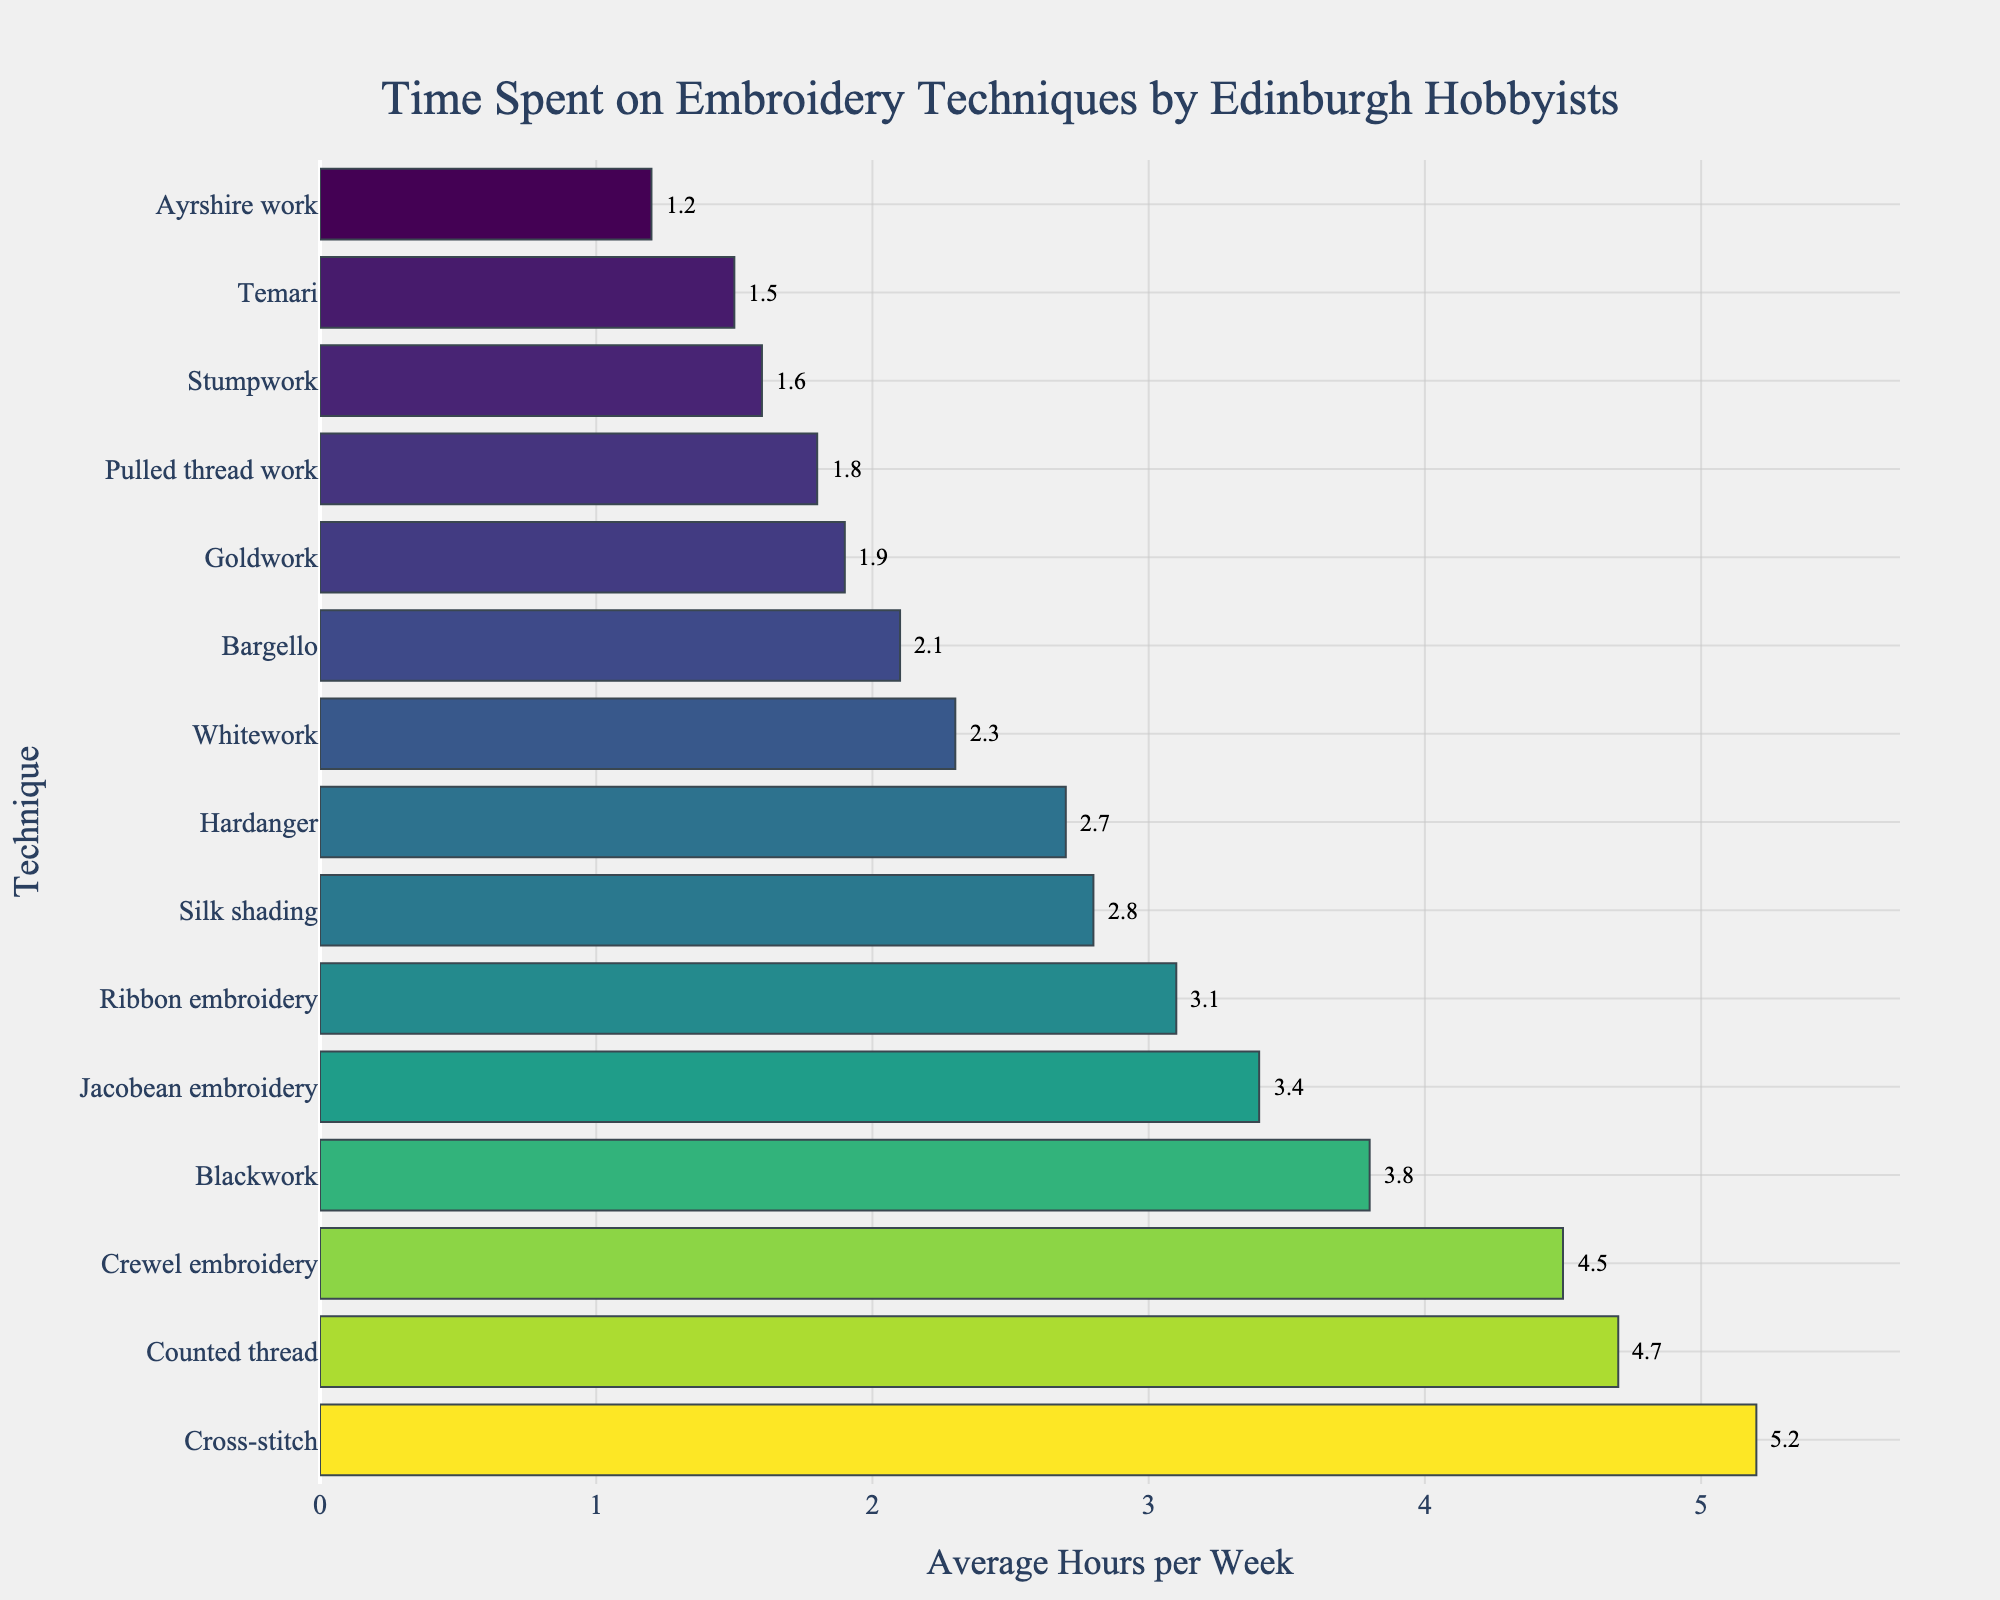What's the total average hours spent on Cross-stitch, Crewel embroidery, and Counted thread? Look at the average hours per week for Cross-stitch (5.2), Crewel embroidery (4.5), and Counted thread (4.7). Sum them up: 5.2 + 4.5 + 4.7 = 14.4 hours
Answer: 14.4 hours Which technique has the least amount of time spent per week? Look at the bar chart and identify the shortest bar, which corresponds to Ayrshire work with 1.2 hours per week.
Answer: Ayrshire work How much more time is spent on Cross-stitch than Hardanger? Identify the average hours per week for Cross-stitch (5.2) and Hardanger (2.7). Calculate the difference: 5.2 - 2.7 = 2.5 hours
Answer: 2.5 hours What’s the average of the three techniques with the highest time spent? Identify the three techniques with the highest average hours: Cross-stitch (5.2), Counted thread (4.7), and Crewel embroidery (4.5). Calculate the average: (5.2 + 4.7 + 4.5) / 3 = 4.8 hours
Answer: 4.8 hours Which two techniques have a combined average weekly time of less than 3 hours? Identify techniques with low average hours: Ayrshire work (1.2) and Temari (1.5). Sum them: 1.2 + 1.5 = 2.7 hours
Answer: Ayrshire work and Temari What’s the difference in time spent between the most and least popular technique? Identify the most popular (Cross-stitch, 5.2 hours) and least popular (Ayrshire work, 1.2 hours). Calculate the difference: 5.2 - 1.2 = 4 hours
Answer: 4 hours Which technique has an average time less than 2 but more than 1 hour? Identify techniques within this range: Stumpwork (1.6 hours) and Temari (1.5 hours).
Answer: Stumpwork and Temari Which techniques have an average time greater than 3 and less than 5 hours? Identify the techniques within this range: Blackwork (3.8), Crewel embroidery (4.5), Ribbon embroidery (3.1), Jacobean embroidery (3.4), and Counted thread (4.7).
Answer: Blackwork, Crewel embroidery, Ribbon embroidery, Jacobean embroidery, and Counted thread Which technique is represented by the second shortest bar in the chart? The second shortest bar represents Temari with 1.5 hours per week.
Answer: Temari On average, how much time is spent on Blackwork and Goldwork combined? Determine the average hours for Blackwork (3.8) and Goldwork (1.9). Sum them up: 3.8 + 1.9 = 5.7 hours
Answer: 5.7 hours 